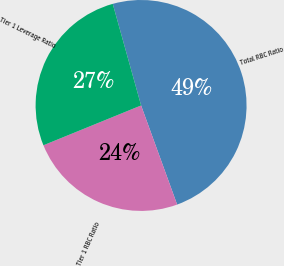Convert chart to OTSL. <chart><loc_0><loc_0><loc_500><loc_500><pie_chart><fcel>Total RBC Ratio<fcel>Tier 1 RBC Ratio<fcel>Tier 1 Leverage Ratio<nl><fcel>48.78%<fcel>24.39%<fcel>26.83%<nl></chart> 